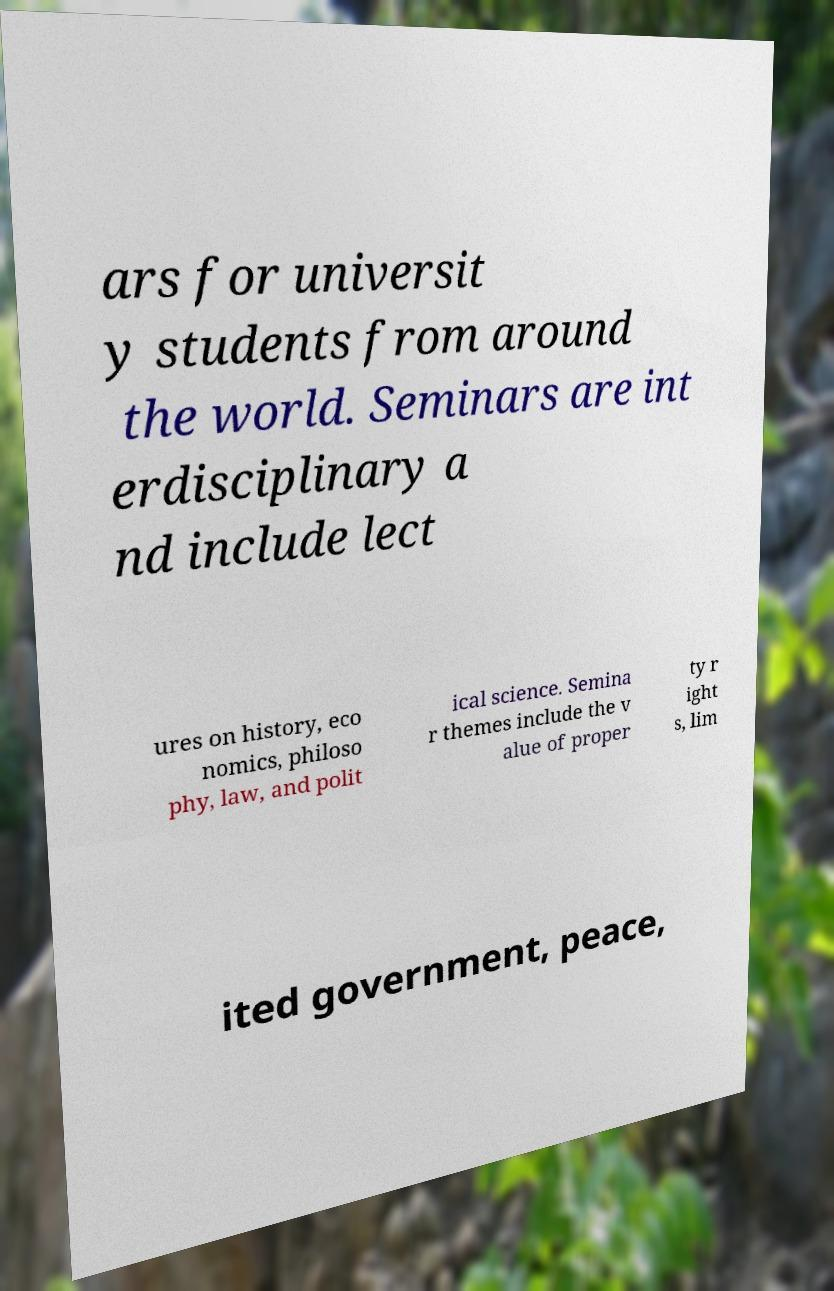Could you assist in decoding the text presented in this image and type it out clearly? ars for universit y students from around the world. Seminars are int erdisciplinary a nd include lect ures on history, eco nomics, philoso phy, law, and polit ical science. Semina r themes include the v alue of proper ty r ight s, lim ited government, peace, 